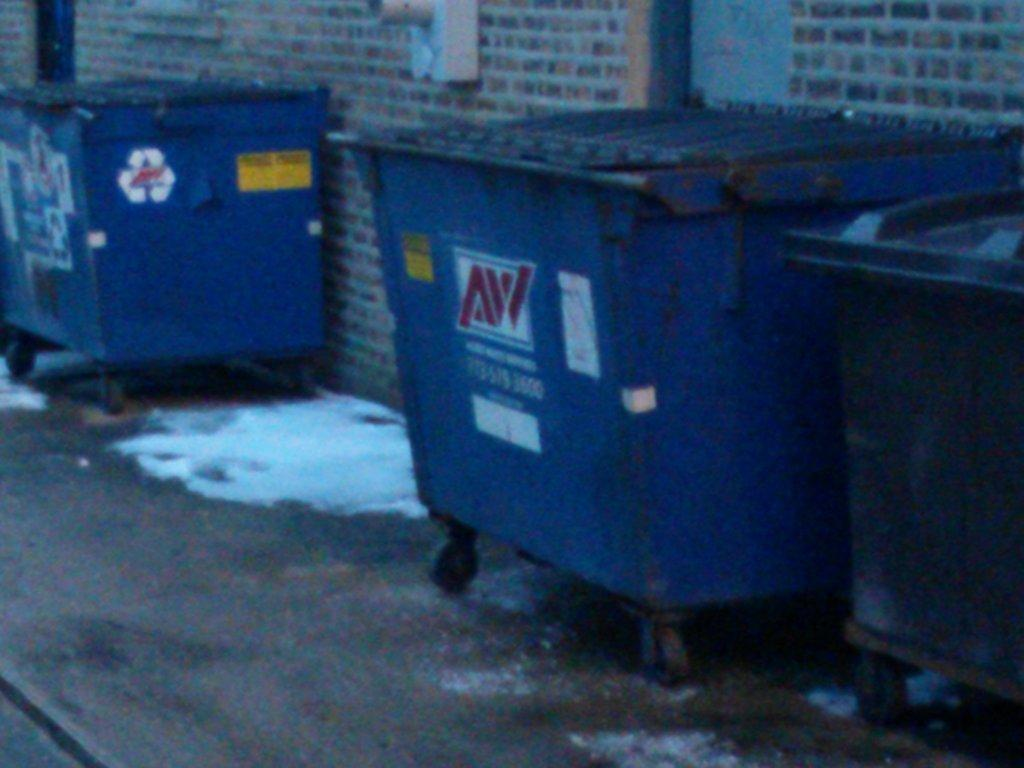<image>
Write a terse but informative summary of the picture. Dumpsters from the AW company sit in an alley. 